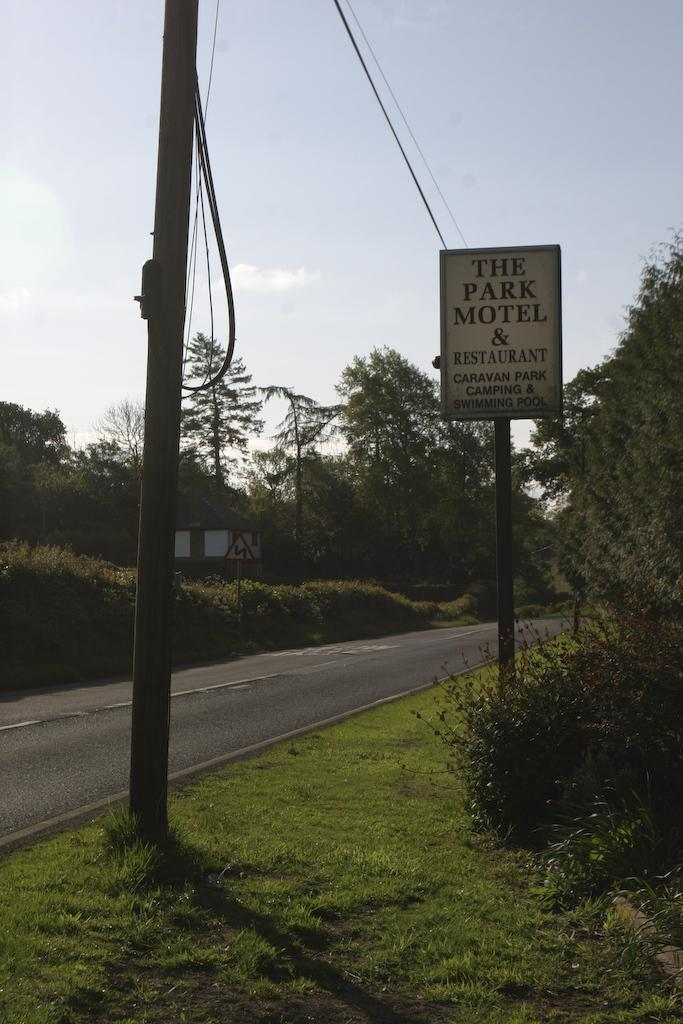What is the main object in the image? There is a name board in the image. What other structures or objects can be seen in the image? There are poles, wires, trees, a house, plants, grass, and a road visible in the image. What is the background of the image? The sky is visible in the background of the image. Can you describe the reaction of the snake to the presence of the snail in the image? There are no snakes or snails present in the image, so it is not possible to describe their reactions. 